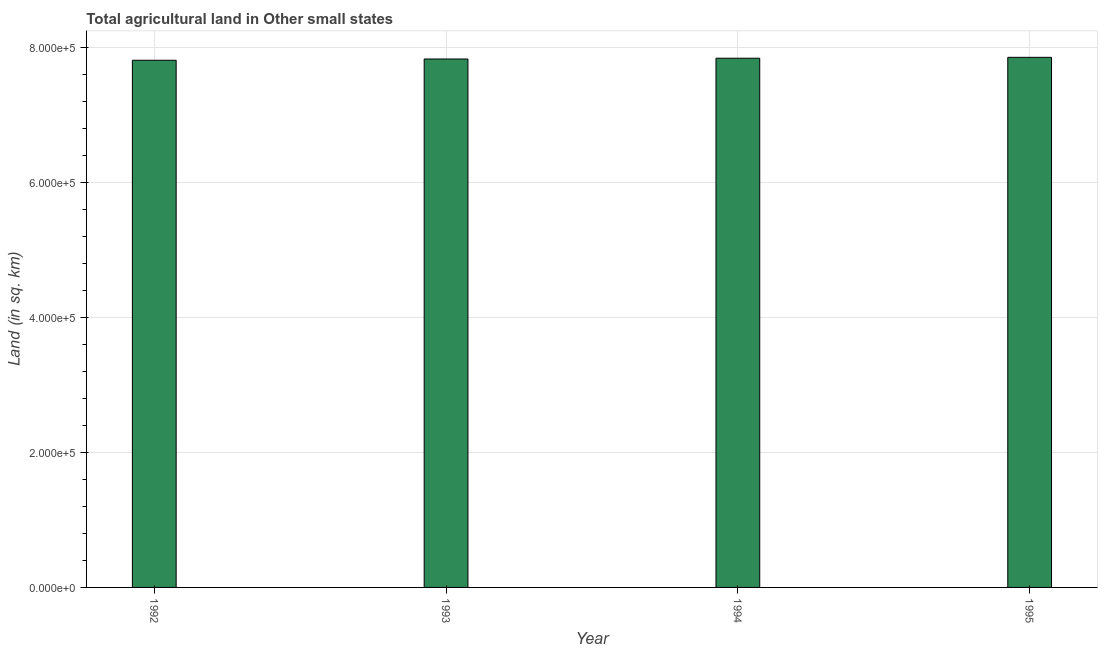Does the graph contain grids?
Ensure brevity in your answer.  Yes. What is the title of the graph?
Provide a succinct answer. Total agricultural land in Other small states. What is the label or title of the X-axis?
Provide a short and direct response. Year. What is the label or title of the Y-axis?
Offer a very short reply. Land (in sq. km). What is the agricultural land in 1994?
Provide a succinct answer. 7.84e+05. Across all years, what is the maximum agricultural land?
Your answer should be very brief. 7.86e+05. Across all years, what is the minimum agricultural land?
Provide a succinct answer. 7.81e+05. In which year was the agricultural land maximum?
Make the answer very short. 1995. What is the sum of the agricultural land?
Make the answer very short. 3.13e+06. What is the difference between the agricultural land in 1993 and 1995?
Offer a very short reply. -2470. What is the average agricultural land per year?
Keep it short and to the point. 7.84e+05. What is the median agricultural land?
Give a very brief answer. 7.84e+05. Do a majority of the years between 1992 and 1995 (inclusive) have agricultural land greater than 640000 sq. km?
Offer a very short reply. Yes. What is the ratio of the agricultural land in 1992 to that in 1994?
Provide a short and direct response. 1. Is the difference between the agricultural land in 1992 and 1994 greater than the difference between any two years?
Your answer should be very brief. No. What is the difference between the highest and the second highest agricultural land?
Keep it short and to the point. 1330. Is the sum of the agricultural land in 1994 and 1995 greater than the maximum agricultural land across all years?
Your answer should be compact. Yes. What is the difference between the highest and the lowest agricultural land?
Keep it short and to the point. 4350. How many years are there in the graph?
Your answer should be very brief. 4. What is the difference between two consecutive major ticks on the Y-axis?
Ensure brevity in your answer.  2.00e+05. What is the Land (in sq. km) in 1992?
Offer a very short reply. 7.81e+05. What is the Land (in sq. km) in 1993?
Your answer should be compact. 7.83e+05. What is the Land (in sq. km) of 1994?
Provide a short and direct response. 7.84e+05. What is the Land (in sq. km) in 1995?
Ensure brevity in your answer.  7.86e+05. What is the difference between the Land (in sq. km) in 1992 and 1993?
Your answer should be very brief. -1880. What is the difference between the Land (in sq. km) in 1992 and 1994?
Your answer should be very brief. -3020. What is the difference between the Land (in sq. km) in 1992 and 1995?
Make the answer very short. -4350. What is the difference between the Land (in sq. km) in 1993 and 1994?
Provide a short and direct response. -1140. What is the difference between the Land (in sq. km) in 1993 and 1995?
Provide a short and direct response. -2470. What is the difference between the Land (in sq. km) in 1994 and 1995?
Make the answer very short. -1330. What is the ratio of the Land (in sq. km) in 1992 to that in 1993?
Provide a succinct answer. 1. What is the ratio of the Land (in sq. km) in 1993 to that in 1994?
Make the answer very short. 1. 